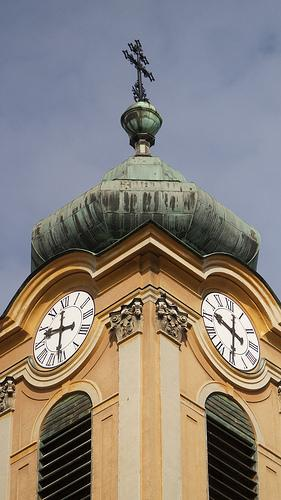Explain the appearance of the top of the building and its color. There is a tan structure with decorative designs near the top of the building. Which item is on the right side of the tower and what is its color? A round clock is on the right side of the tower and has a black and white color. Please describe what can be observed at the top of the clock tower. A cross can be seen at the top of the clock tower. Describe what the Roman numeral 3 looks like on the left side clock. On the left side clock, the Roman numeral 3 appears as three black vertical lines. What is the main object on top of the building? A weather vane is on top of the building. Mention the color of the ball below the weather vane and describe its position. The ball is green and it is positioned under the weather vane. In a few words, summarize the characteristics of the clock tower and its surroundings. Historical beige clock tower with two white-faced Roman numeral clocks, green steeple, and white clouds in a blue sky. Can you identify two features of the clock on the building? The clock face is white, and it has black hands with Roman numerals. State a detail about the building's appearance and something about its windows. The building is tan and the windows have slats. What distinguishes the hour and minute hands on the white clock face? The hands on the clock are black, while the clock face is white. 